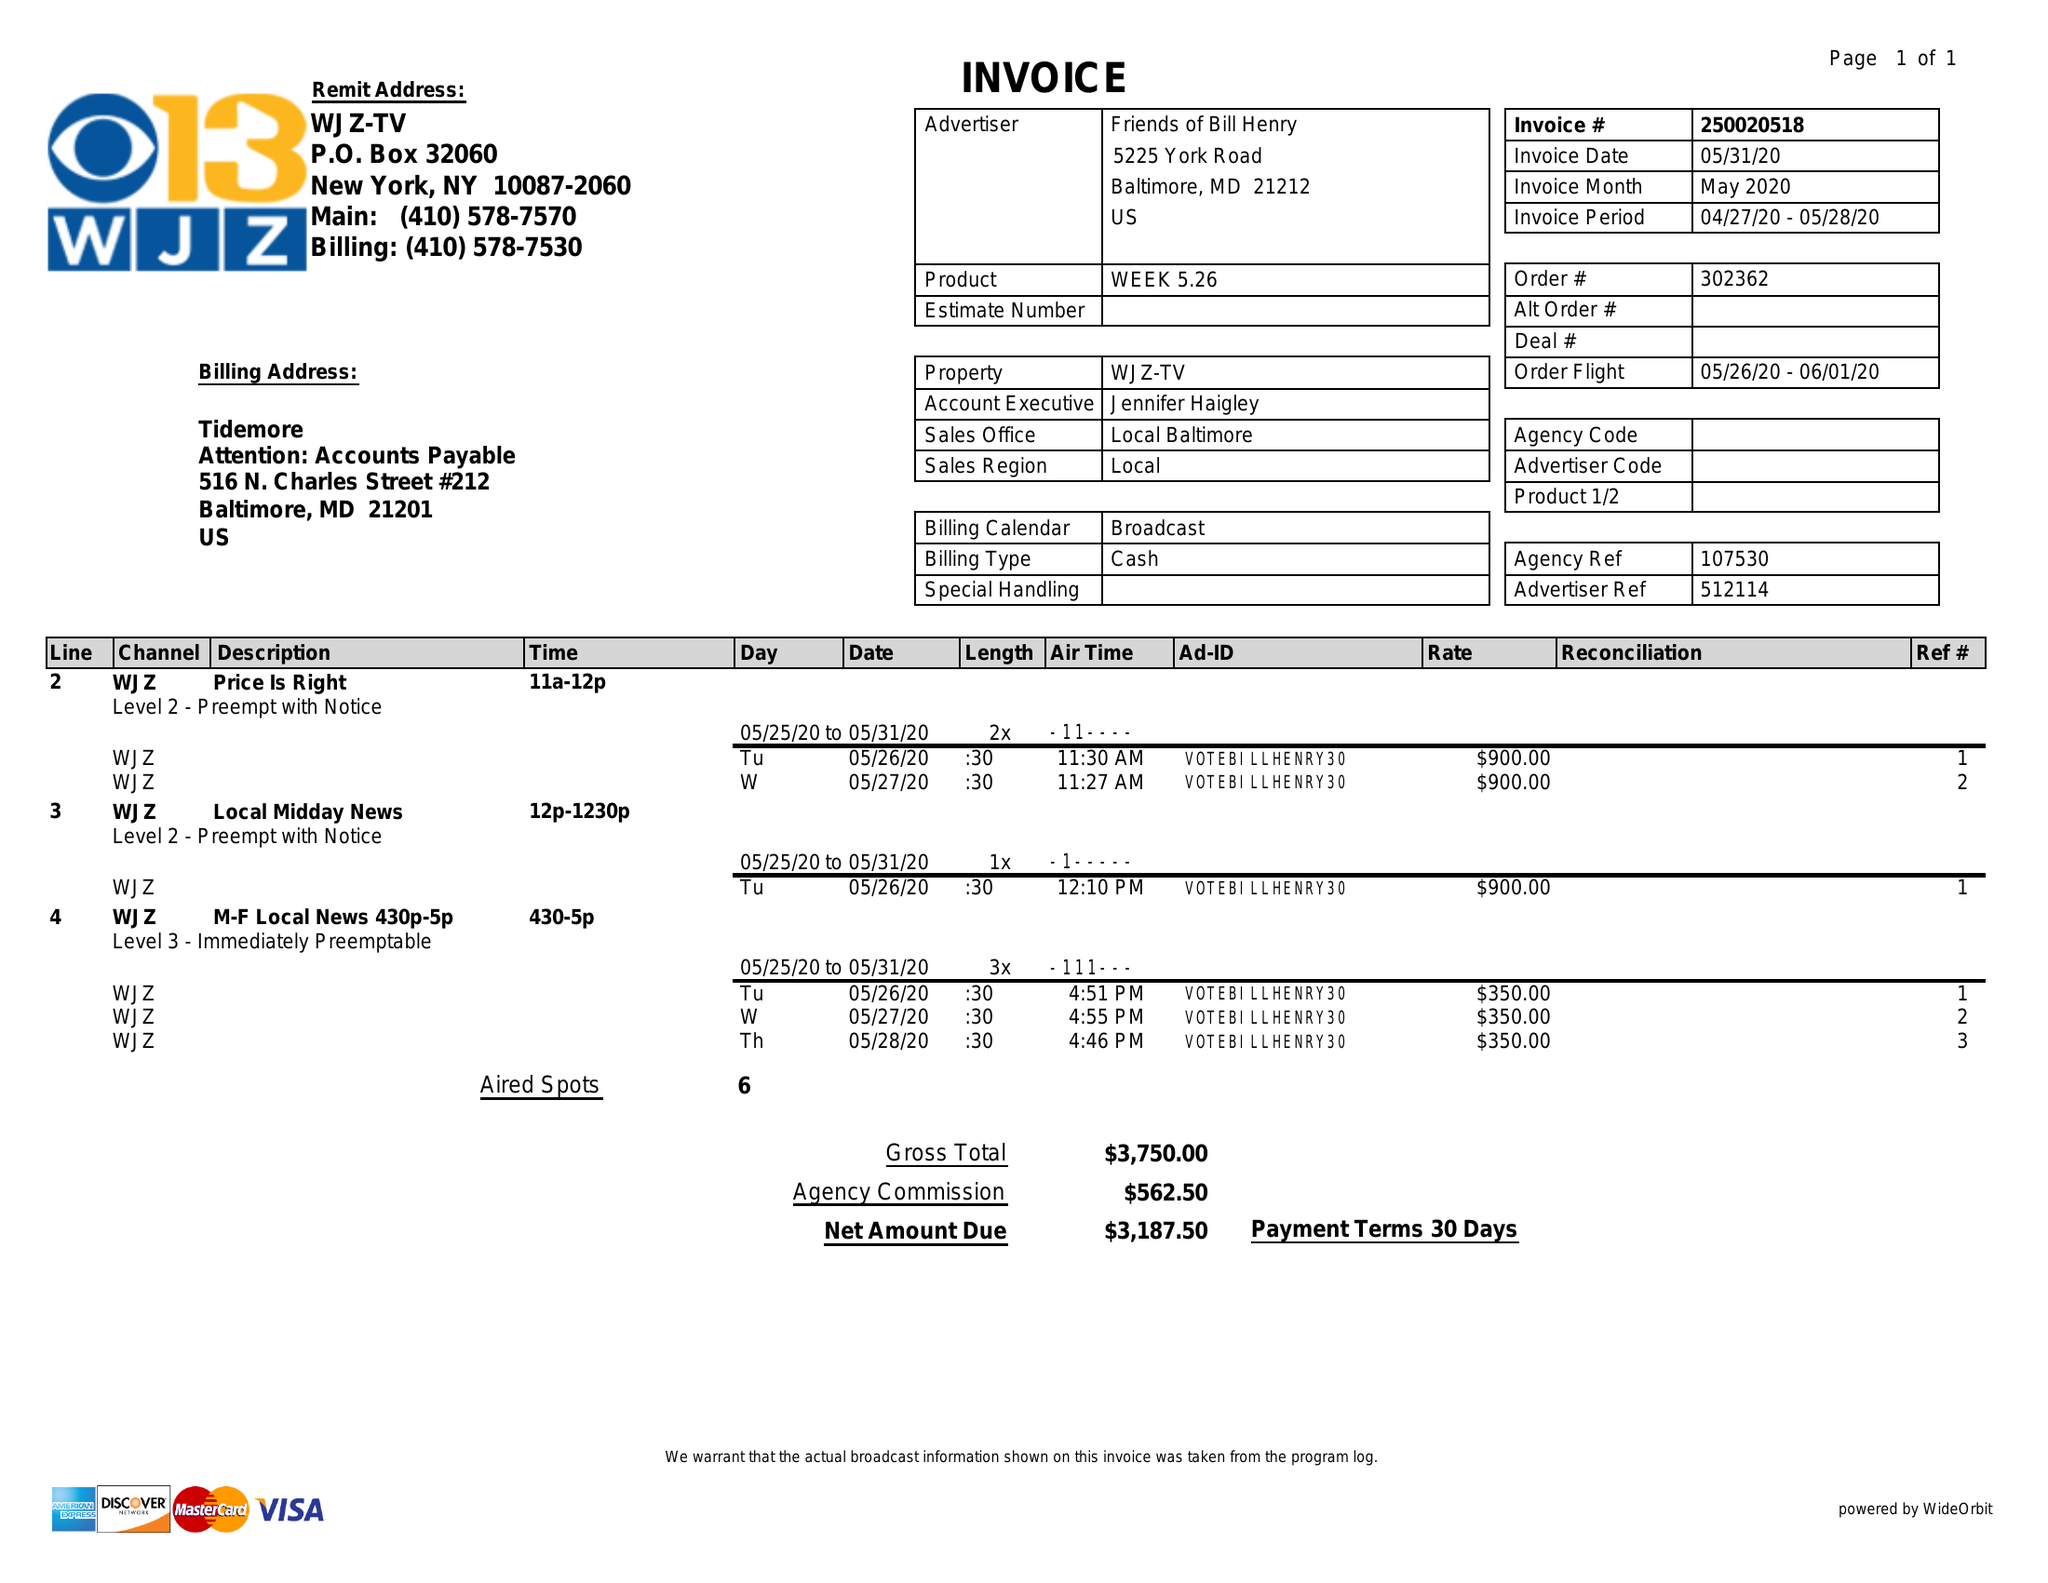What is the value for the advertiser?
Answer the question using a single word or phrase. FRIENDS OF BILL HENRY 